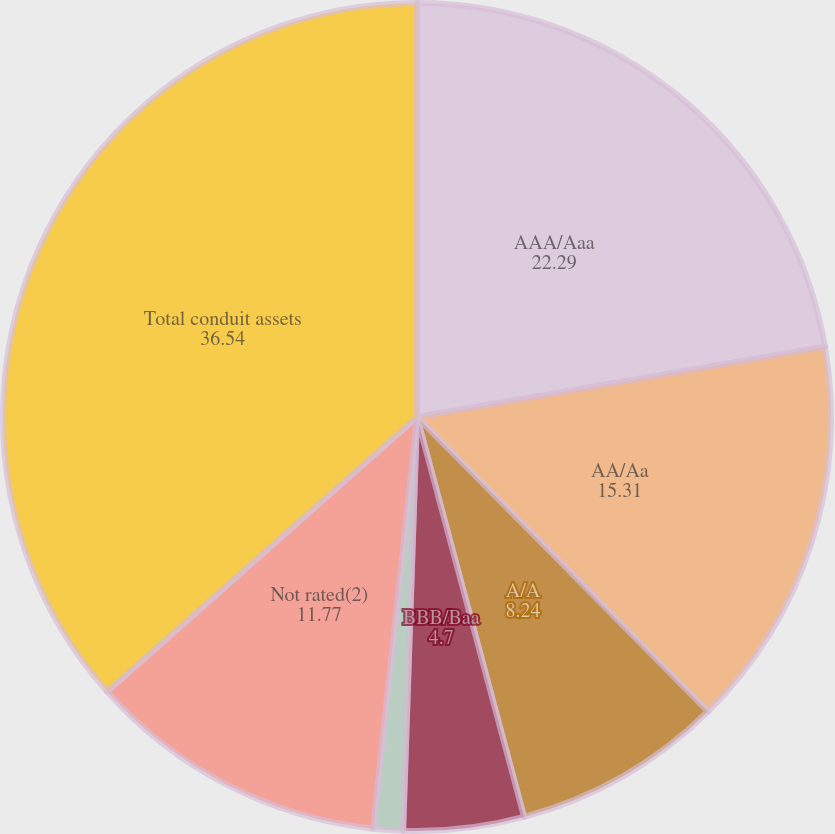Convert chart. <chart><loc_0><loc_0><loc_500><loc_500><pie_chart><fcel>AAA/Aaa<fcel>AA/Aa<fcel>A/A<fcel>BBB/Baa<fcel>BB/Ba<fcel>Not rated(2)<fcel>Total conduit assets<nl><fcel>22.29%<fcel>15.31%<fcel>8.24%<fcel>4.7%<fcel>1.16%<fcel>11.77%<fcel>36.54%<nl></chart> 